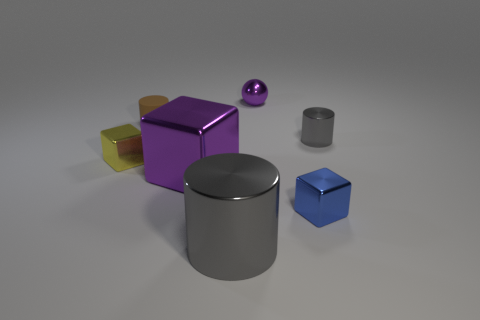There is a purple object to the right of the gray metallic cylinder in front of the shiny block left of the tiny brown cylinder; what shape is it?
Offer a very short reply. Sphere. Is the number of metallic things that are on the right side of the large gray metallic cylinder greater than the number of gray things?
Your answer should be very brief. Yes. There is a small object left of the brown rubber object; is its shape the same as the rubber thing?
Your response must be concise. No. What material is the tiny cylinder in front of the small brown cylinder?
Provide a short and direct response. Metal. How many other small things have the same shape as the brown thing?
Your response must be concise. 1. There is a gray cylinder in front of the small metal block that is on the right side of the yellow metal cube; what is its material?
Your answer should be very brief. Metal. What shape is the big metal object that is the same color as the shiny sphere?
Your answer should be very brief. Cube. Are there any yellow things made of the same material as the big cylinder?
Ensure brevity in your answer.  Yes. The yellow thing is what shape?
Ensure brevity in your answer.  Cube. What number of big metallic cylinders are there?
Provide a succinct answer. 1. 